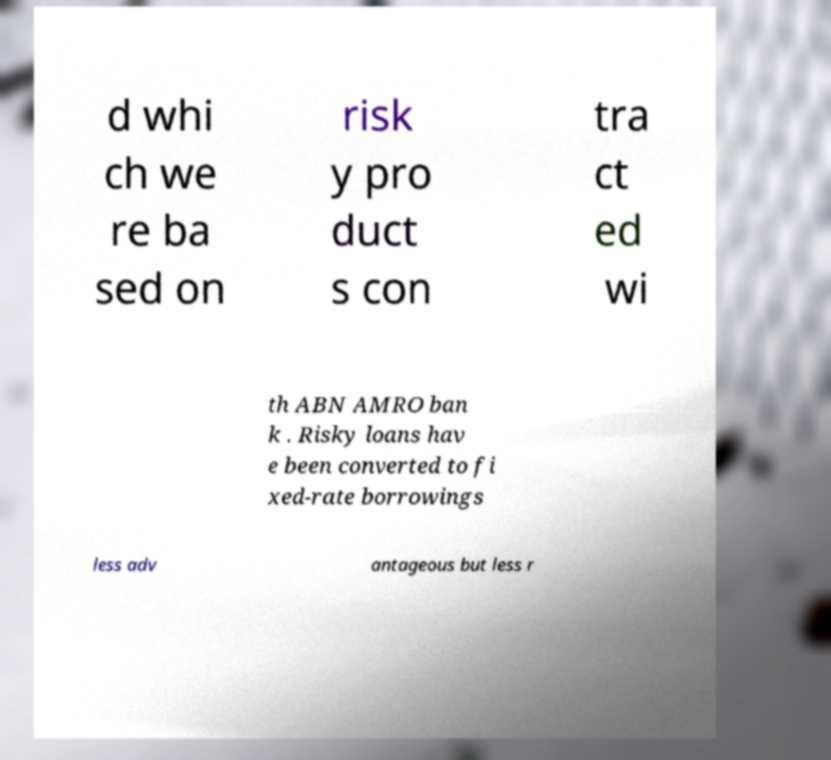Please read and relay the text visible in this image. What does it say? d whi ch we re ba sed on risk y pro duct s con tra ct ed wi th ABN AMRO ban k . Risky loans hav e been converted to fi xed-rate borrowings less adv antageous but less r 